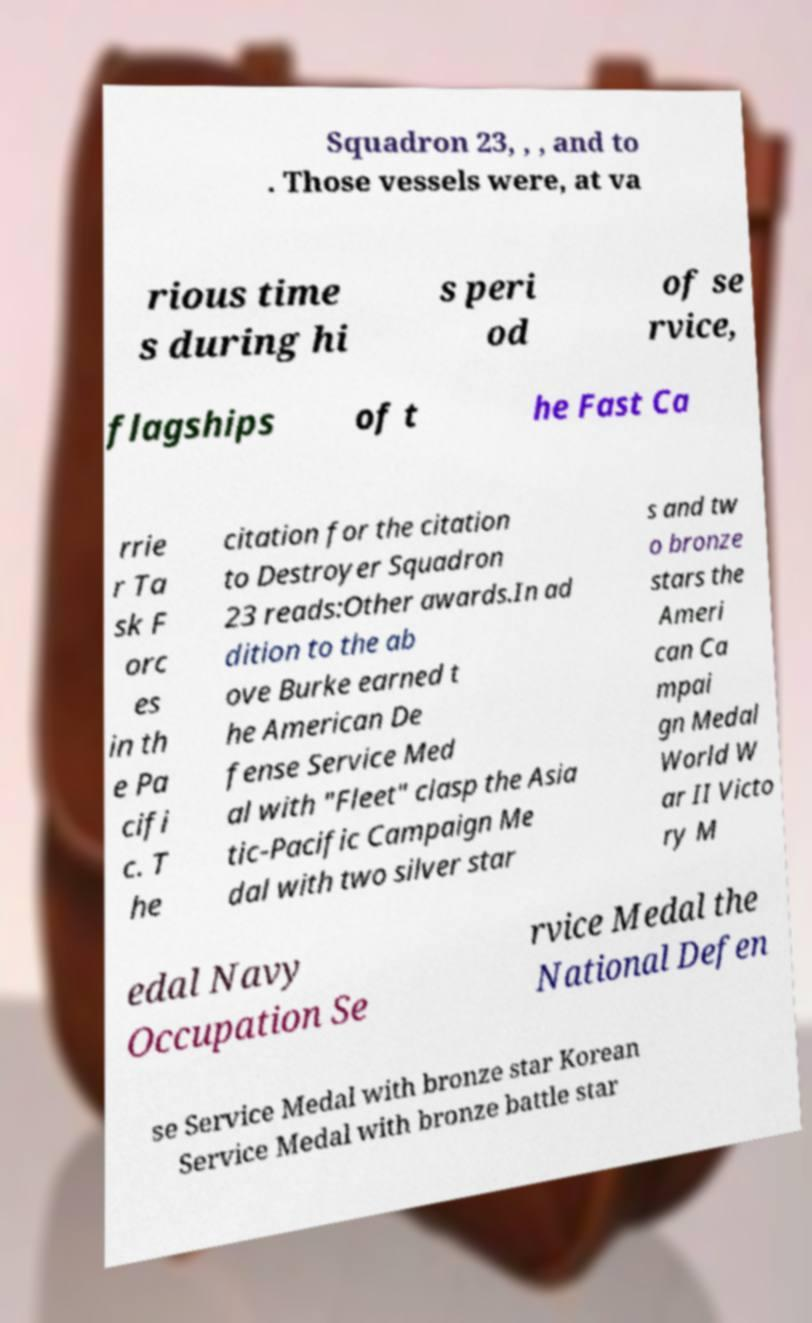Please identify and transcribe the text found in this image. Squadron 23, , , and to . Those vessels were, at va rious time s during hi s peri od of se rvice, flagships of t he Fast Ca rrie r Ta sk F orc es in th e Pa cifi c. T he citation for the citation to Destroyer Squadron 23 reads:Other awards.In ad dition to the ab ove Burke earned t he American De fense Service Med al with "Fleet" clasp the Asia tic-Pacific Campaign Me dal with two silver star s and tw o bronze stars the Ameri can Ca mpai gn Medal World W ar II Victo ry M edal Navy Occupation Se rvice Medal the National Defen se Service Medal with bronze star Korean Service Medal with bronze battle star 